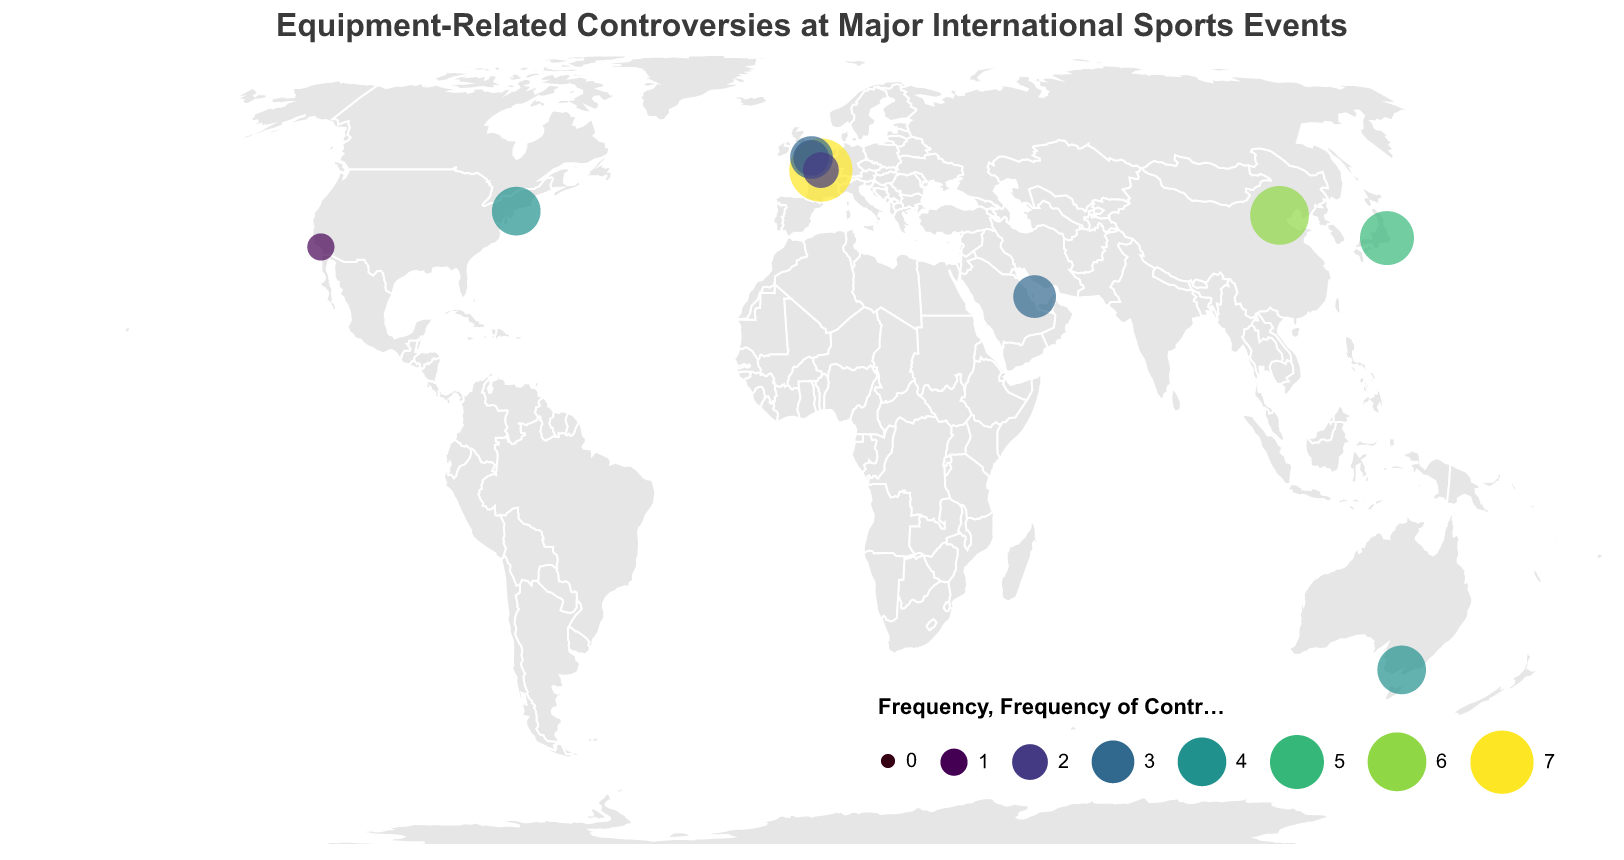What is the title of the figure? The title is typically displayed at the top of the figure. In this case, it reads "Equipment-Related Controversies at Major International Sports Events".
Answer: Equipment-Related Controversies at Major International Sports Events Which city had the highest frequency of equipment controversies? By examining the larger circles in the plot, Paris for the Tour de France 2021 has the largest circle, indicating the highest frequency of controversies.
Answer: Paris What is the frequency of equipment-related controversies at the Olympics 2020 in Tokyo? Look for the corresponding point on the map at Tokyo, and the size or color scale will indicate the frequency.
Answer: 5 How many events took place in London, UK? London appears at two different locations on the plot, indicating there were multiple events. Count these occurrences.
Answer: 2 Which country has the most events listed on the figure? Identify the countries and count the number of events in each. UK has two event entries both in London.
Answer: UK What is the latitude and longitude of the Winter Olympics 2022 in Beijing? Find the Winter Olympics 2022 on the map and refer to its data entry.
Answer: 39.9042, 116.4074 Compare the frequency of equipment controversies between the US Open Tennis 2022 and the Super Bowl LVI. Which had more controversies? Locate both events on the map and compare the size/color of their circles.
Answer: US Open Tennis 2022 What is the average frequency of equipment-related controversies across all events? Sum the frequencies of all events (3+5+7+2+4+1+3+2+4+6) = 37 and divide by the number of events (10).
Answer: 3.7 Which event in Paris had fewer equipment-related controversies: Tour de France 2021 or Rugby World Cup 2023? Examine the circles for both events in Paris; the smaller circle corresponds to the Rugby World Cup 2023.
Answer: Rugby World Cup 2023 Are there any sports events in the Southern Hemisphere? If so, which event? Find cities with negative latitude values on the map; Melbourne, Australia qualifies with the Australian Open 2023.
Answer: Australian Open 2023 